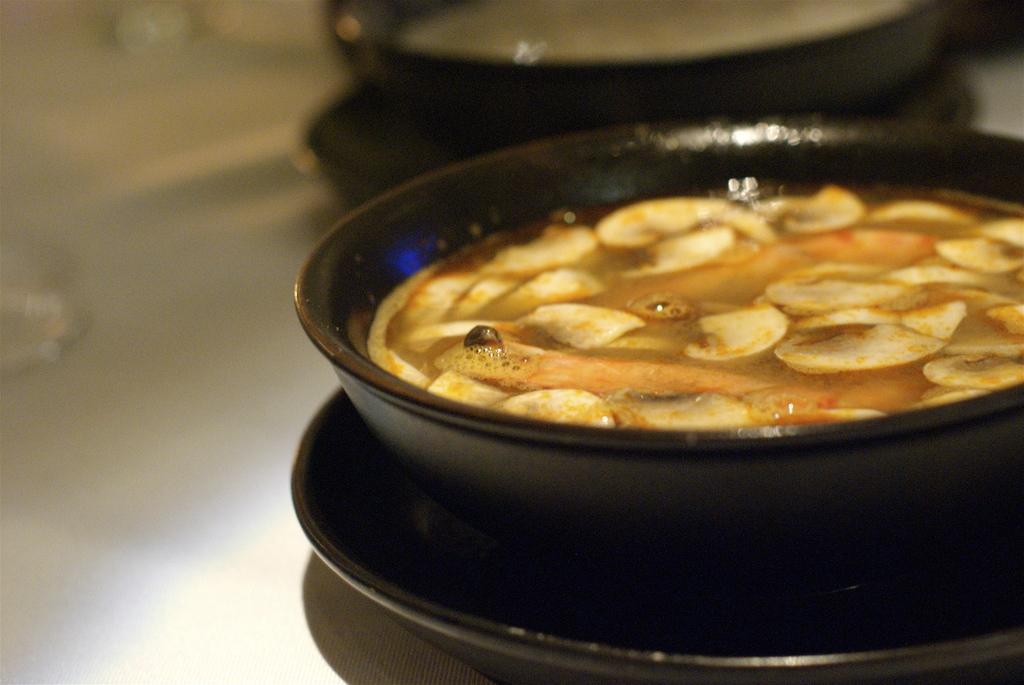How would you summarize this image in a sentence or two? These are the food items in a black color pan. 